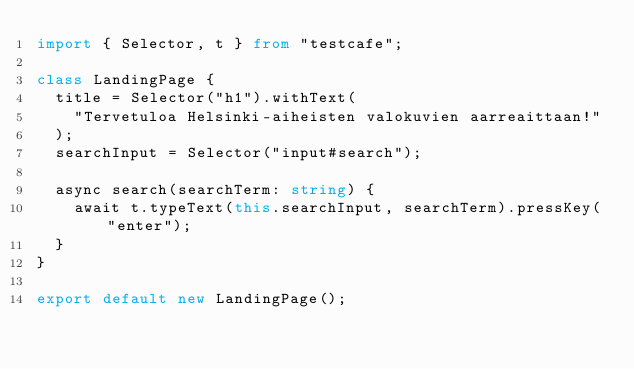Convert code to text. <code><loc_0><loc_0><loc_500><loc_500><_TypeScript_>import { Selector, t } from "testcafe";

class LandingPage {
  title = Selector("h1").withText(
    "Tervetuloa Helsinki-aiheisten valokuvien aarreaittaan!"
  );
  searchInput = Selector("input#search");

  async search(searchTerm: string) {
    await t.typeText(this.searchInput, searchTerm).pressKey("enter");
  }
}

export default new LandingPage();
</code> 